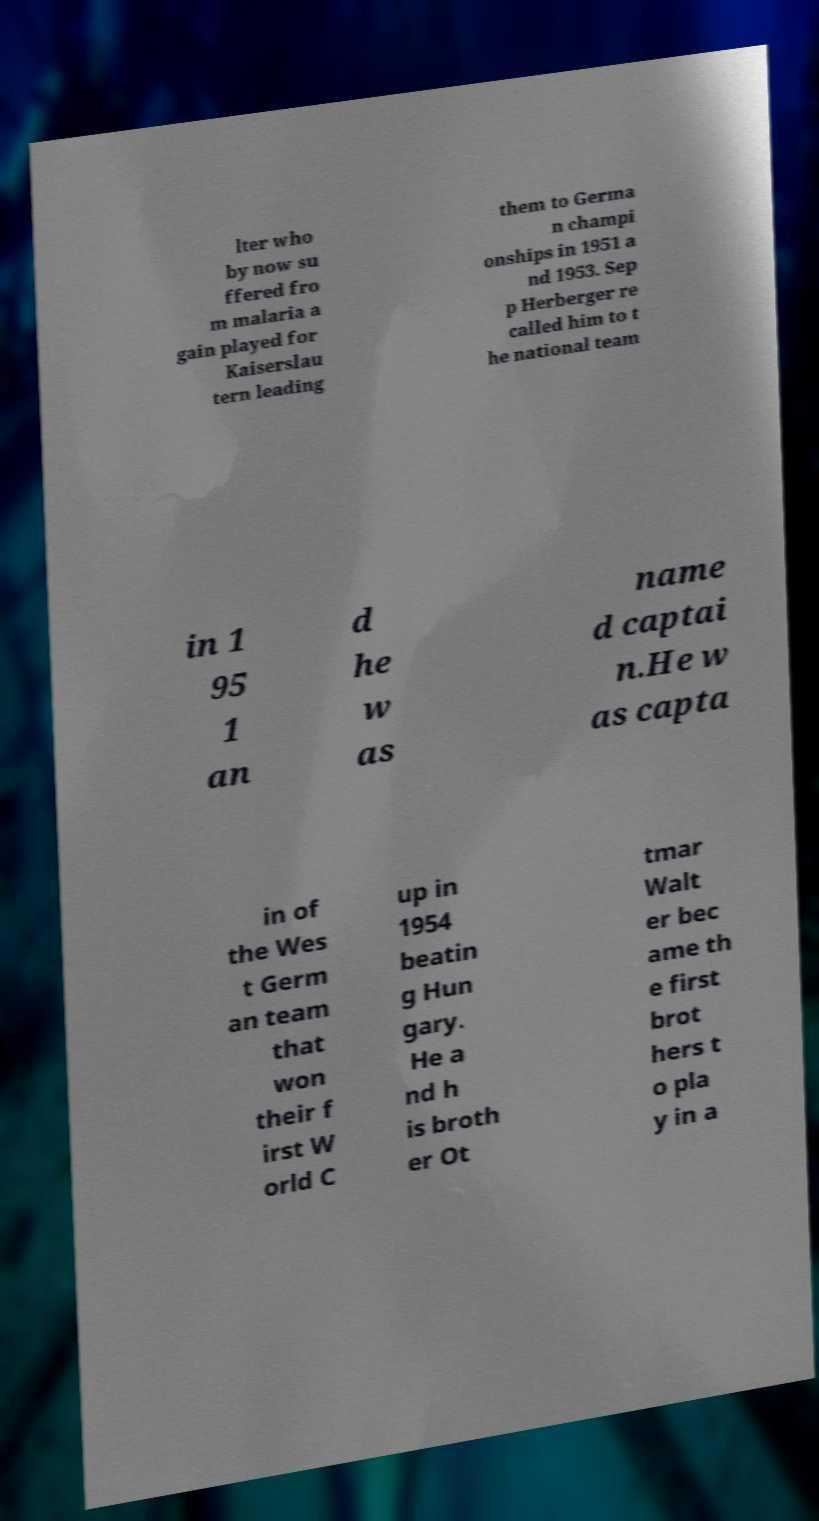Please read and relay the text visible in this image. What does it say? lter who by now su ffered fro m malaria a gain played for Kaiserslau tern leading them to Germa n champi onships in 1951 a nd 1953. Sep p Herberger re called him to t he national team in 1 95 1 an d he w as name d captai n.He w as capta in of the Wes t Germ an team that won their f irst W orld C up in 1954 beatin g Hun gary. He a nd h is broth er Ot tmar Walt er bec ame th e first brot hers t o pla y in a 